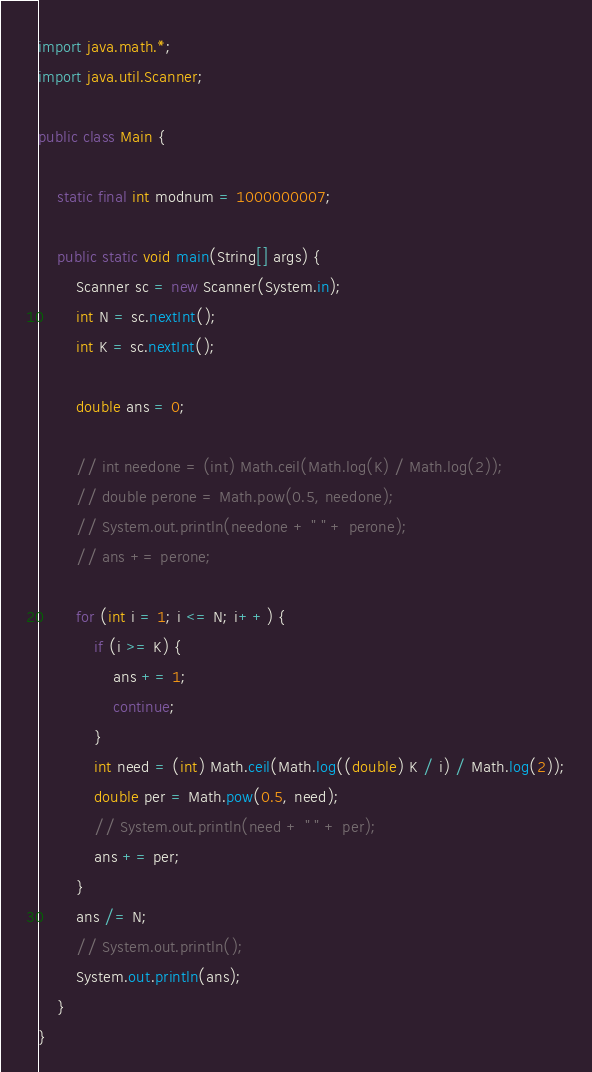Convert code to text. <code><loc_0><loc_0><loc_500><loc_500><_Java_>import java.math.*;
import java.util.Scanner;

public class Main {

    static final int modnum = 1000000007;

    public static void main(String[] args) {
        Scanner sc = new Scanner(System.in);
        int N = sc.nextInt();
        int K = sc.nextInt();

        double ans = 0;

        // int needone = (int) Math.ceil(Math.log(K) / Math.log(2));
        // double perone = Math.pow(0.5, needone);
        // System.out.println(needone + " " + perone);
        // ans += perone;

        for (int i = 1; i <= N; i++) {
            if (i >= K) {
                ans += 1;
                continue;
            }
            int need = (int) Math.ceil(Math.log((double) K / i) / Math.log(2));
            double per = Math.pow(0.5, need);
            // System.out.println(need + " " + per);
            ans += per;
        }
        ans /= N;
        // System.out.println();
        System.out.println(ans);
    }
}</code> 